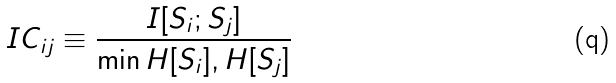Convert formula to latex. <formula><loc_0><loc_0><loc_500><loc_500>I C _ { i j } \equiv \frac { I [ S _ { i } ; S _ { j } ] } { \min { H [ S _ { i } ] , H [ S _ { j } ] } }</formula> 